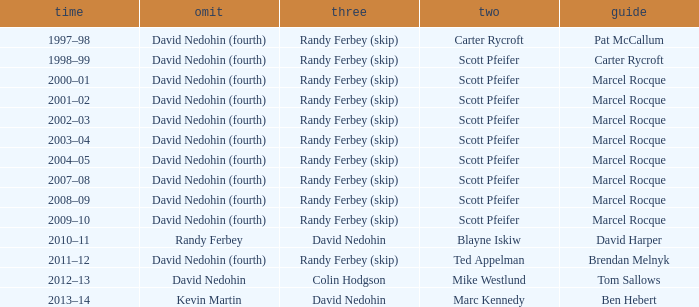Which Second has a Third of david nedohin, and a Lead of ben hebert? Marc Kennedy. 